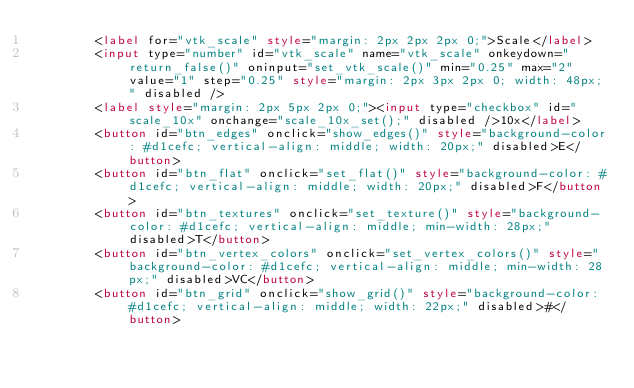<code> <loc_0><loc_0><loc_500><loc_500><_HTML_>        <label for="vtk_scale" style="margin: 2px 2px 2px 0;">Scale</label>
        <input type="number" id="vtk_scale" name="vtk_scale" onkeydown="return_false()" oninput="set_vtk_scale()" min="0.25" max="2" value="1" step="0.25" style="margin: 2px 3px 2px 0; width: 48px;" disabled />
        <label style="margin: 2px 5px 2px 0;"><input type="checkbox" id="scale_10x" onchange="scale_10x_set();" disabled />10x</label>
        <button id="btn_edges" onclick="show_edges()" style="background-color: #d1cefc; vertical-align: middle; width: 20px;" disabled>E</button>
        <button id="btn_flat" onclick="set_flat()" style="background-color: #d1cefc; vertical-align: middle; width: 20px;" disabled>F</button>
        <button id="btn_textures" onclick="set_texture()" style="background-color: #d1cefc; vertical-align: middle; min-width: 28px;" disabled>T</button>
        <button id="btn_vertex_colors" onclick="set_vertex_colors()" style="background-color: #d1cefc; vertical-align: middle; min-width: 28px;" disabled>VC</button>
        <button id="btn_grid" onclick="show_grid()" style="background-color: #d1cefc; vertical-align: middle; width: 22px;" disabled>#</button></code> 